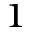Convert formula to latex. <formula><loc_0><loc_0><loc_500><loc_500>^ { 1 }</formula> 